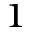Convert formula to latex. <formula><loc_0><loc_0><loc_500><loc_500>^ { 1 }</formula> 